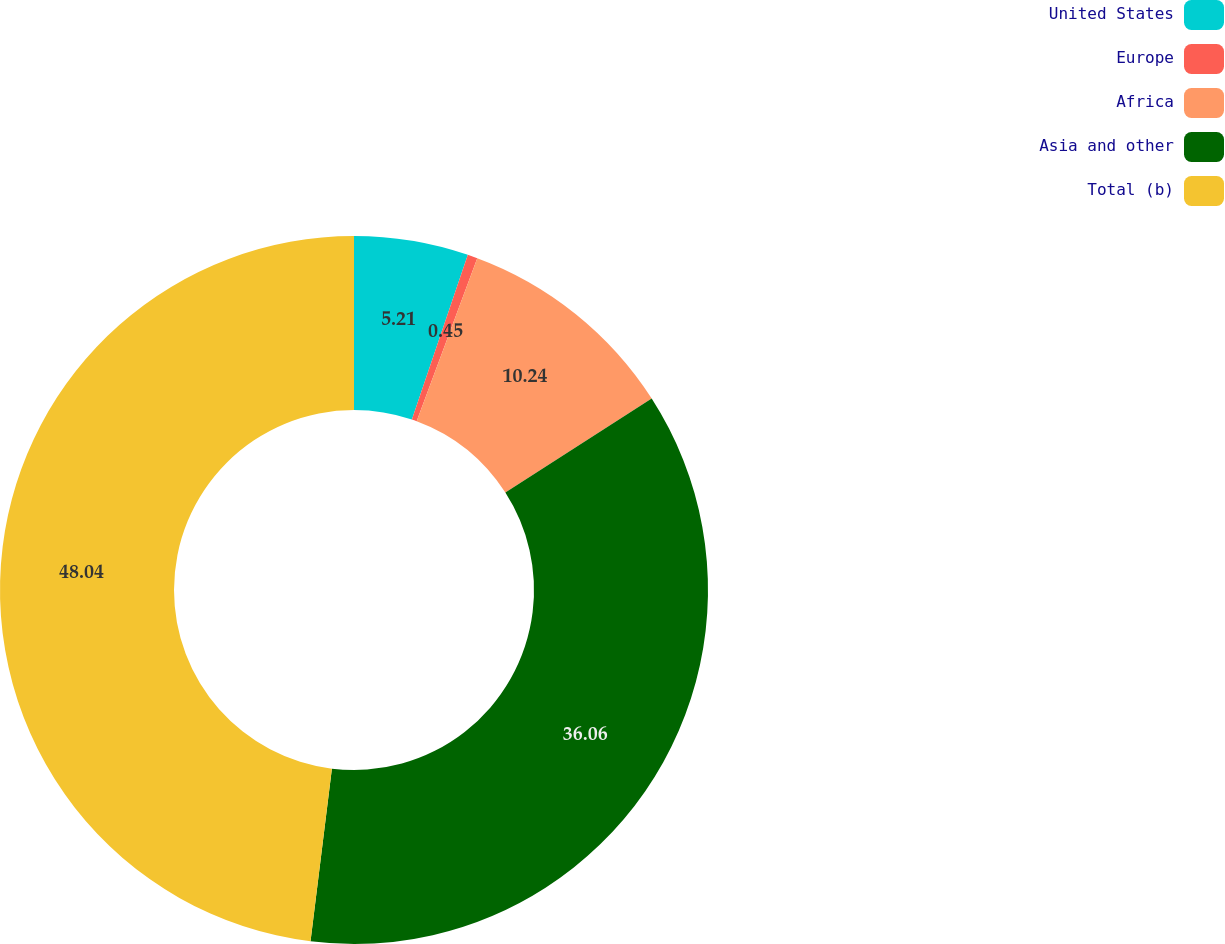<chart> <loc_0><loc_0><loc_500><loc_500><pie_chart><fcel>United States<fcel>Europe<fcel>Africa<fcel>Asia and other<fcel>Total (b)<nl><fcel>5.21%<fcel>0.45%<fcel>10.24%<fcel>36.06%<fcel>48.04%<nl></chart> 